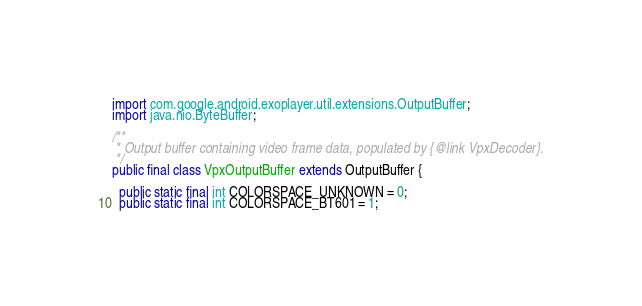Convert code to text. <code><loc_0><loc_0><loc_500><loc_500><_Java_>import com.google.android.exoplayer.util.extensions.OutputBuffer;
import java.nio.ByteBuffer;

/**
 * Output buffer containing video frame data, populated by {@link VpxDecoder}.
 */
public final class VpxOutputBuffer extends OutputBuffer {

  public static final int COLORSPACE_UNKNOWN = 0;
  public static final int COLORSPACE_BT601 = 1;</code> 